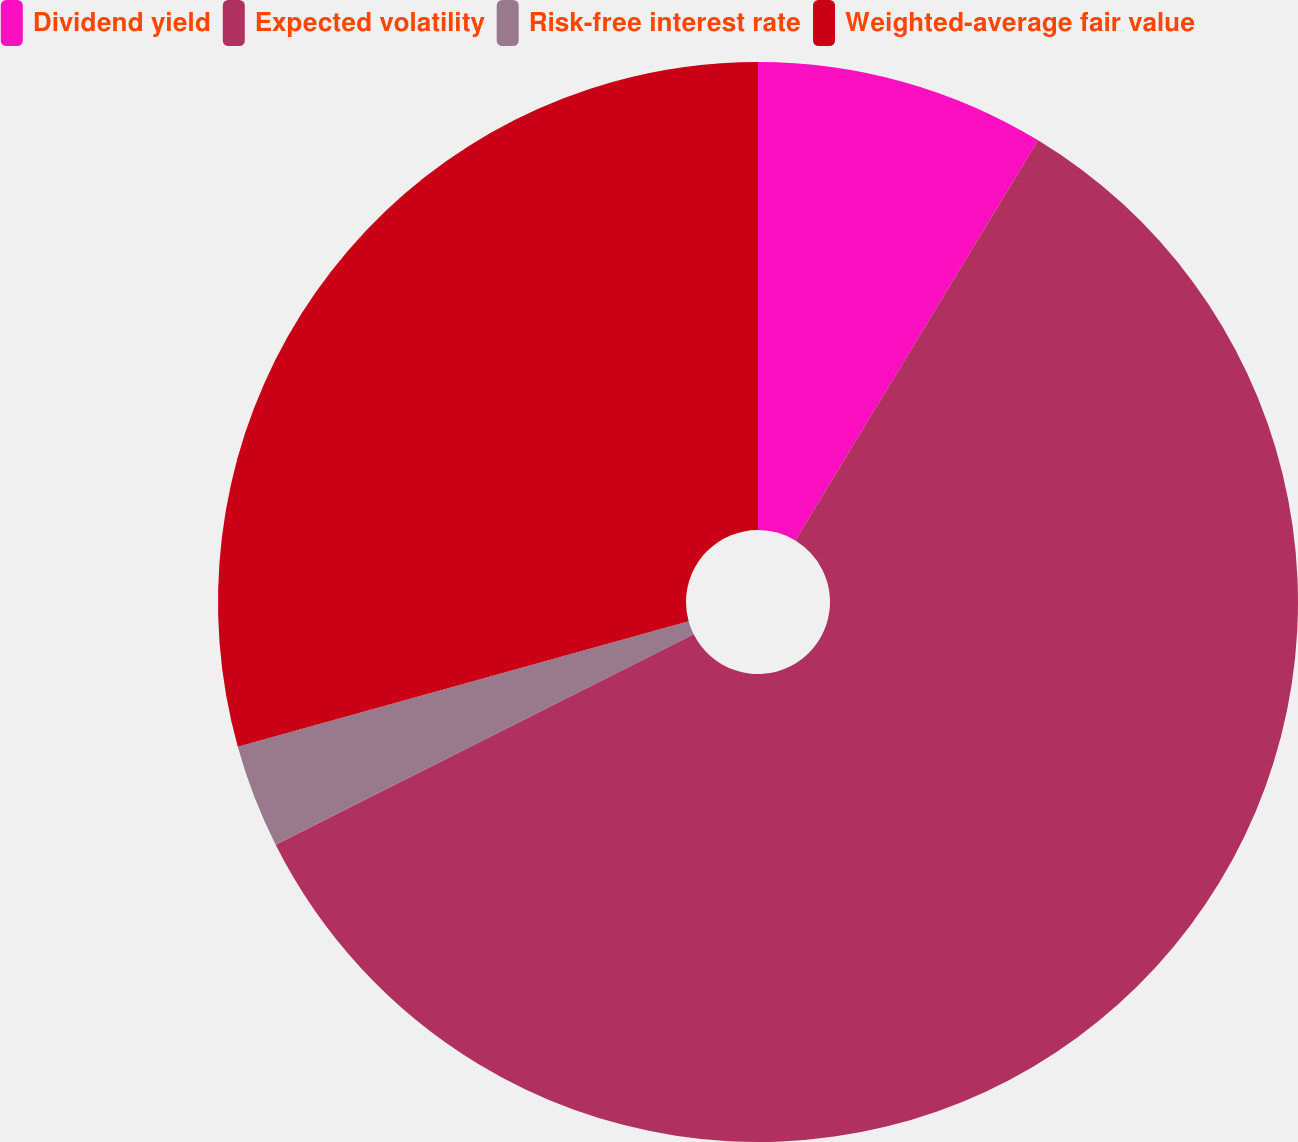<chart> <loc_0><loc_0><loc_500><loc_500><pie_chart><fcel>Dividend yield<fcel>Expected volatility<fcel>Risk-free interest rate<fcel>Weighted-average fair value<nl><fcel>8.68%<fcel>58.9%<fcel>3.1%<fcel>29.32%<nl></chart> 